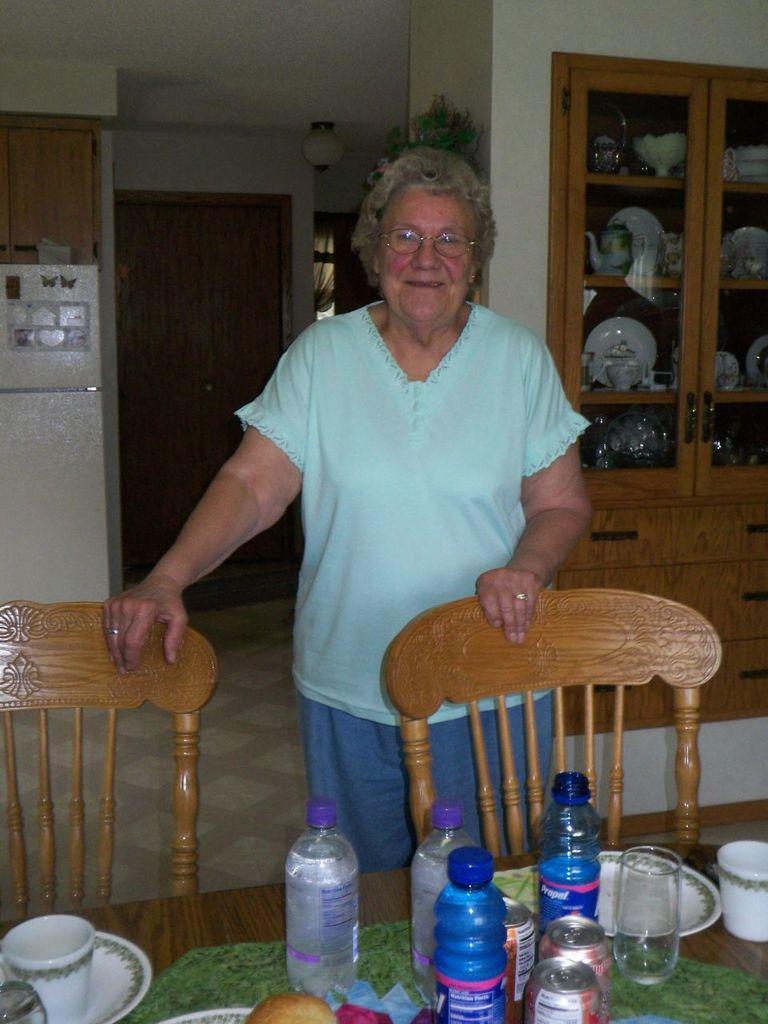Could you give a brief overview of what you see in this image? on the table there are cup, saucer, bottle, tins. there are 2 chairs. behind that a person is standing wearing a green t shirt and a pant. behind that there is a cupboard in which there are vessels. at the back there is a door. 